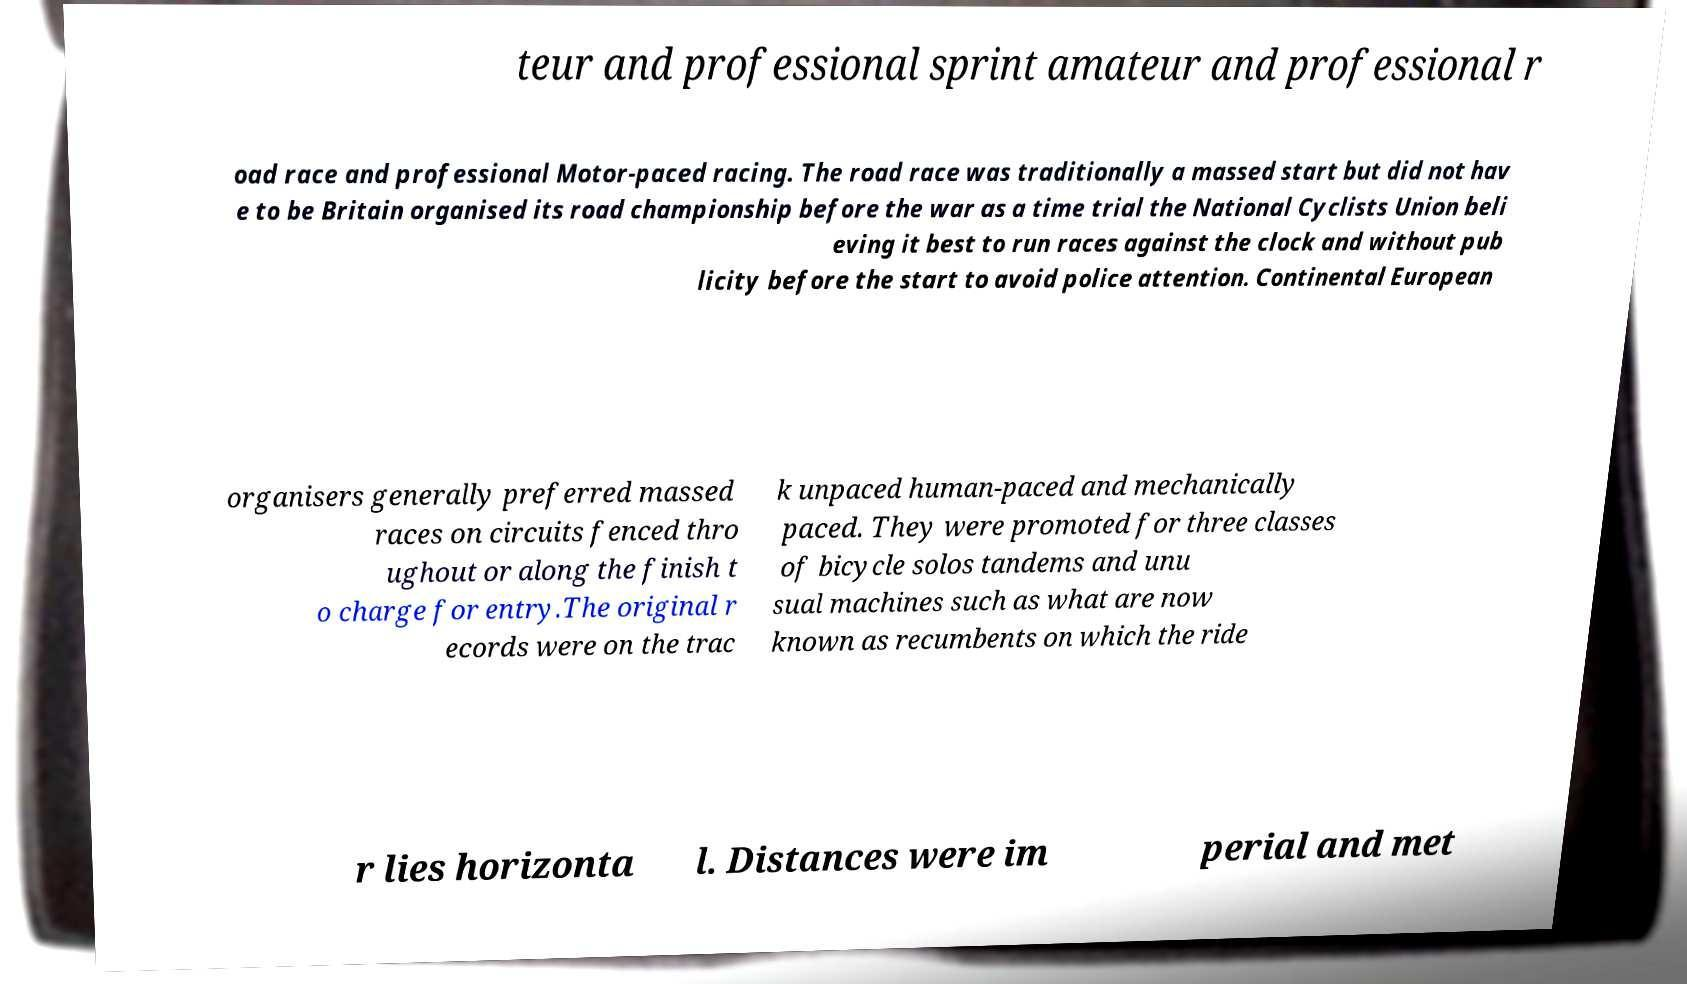Please read and relay the text visible in this image. What does it say? teur and professional sprint amateur and professional r oad race and professional Motor-paced racing. The road race was traditionally a massed start but did not hav e to be Britain organised its road championship before the war as a time trial the National Cyclists Union beli eving it best to run races against the clock and without pub licity before the start to avoid police attention. Continental European organisers generally preferred massed races on circuits fenced thro ughout or along the finish t o charge for entry.The original r ecords were on the trac k unpaced human-paced and mechanically paced. They were promoted for three classes of bicycle solos tandems and unu sual machines such as what are now known as recumbents on which the ride r lies horizonta l. Distances were im perial and met 